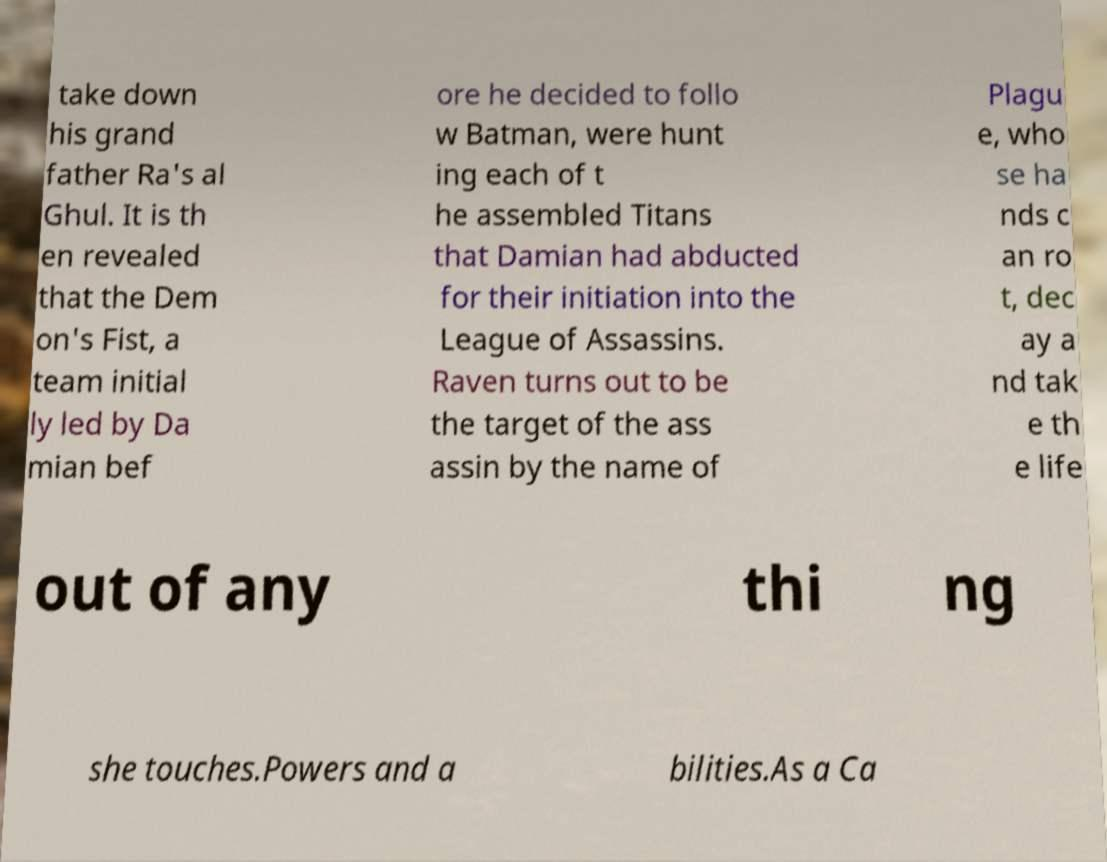Please read and relay the text visible in this image. What does it say? take down his grand father Ra's al Ghul. It is th en revealed that the Dem on's Fist, a team initial ly led by Da mian bef ore he decided to follo w Batman, were hunt ing each of t he assembled Titans that Damian had abducted for their initiation into the League of Assassins. Raven turns out to be the target of the ass assin by the name of Plagu e, who se ha nds c an ro t, dec ay a nd tak e th e life out of any thi ng she touches.Powers and a bilities.As a Ca 